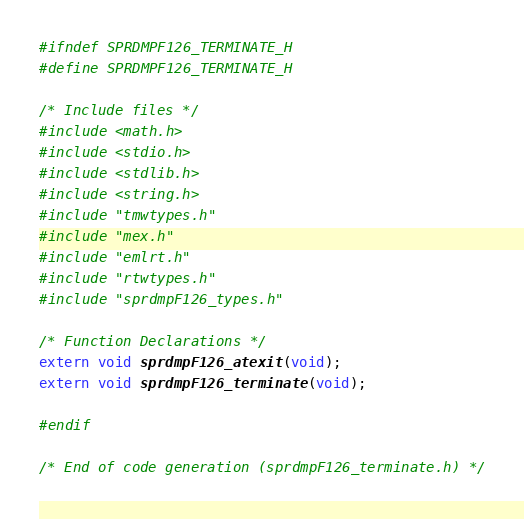<code> <loc_0><loc_0><loc_500><loc_500><_C_>
#ifndef SPRDMPF126_TERMINATE_H
#define SPRDMPF126_TERMINATE_H

/* Include files */
#include <math.h>
#include <stdio.h>
#include <stdlib.h>
#include <string.h>
#include "tmwtypes.h"
#include "mex.h"
#include "emlrt.h"
#include "rtwtypes.h"
#include "sprdmpF126_types.h"

/* Function Declarations */
extern void sprdmpF126_atexit(void);
extern void sprdmpF126_terminate(void);

#endif

/* End of code generation (sprdmpF126_terminate.h) */
</code> 